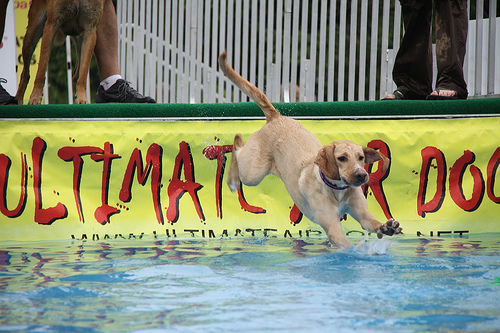<image>
Is there a water on the sign? Yes. Looking at the image, I can see the water is positioned on top of the sign, with the sign providing support. 